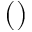Convert formula to latex. <formula><loc_0><loc_0><loc_500><loc_500>( )</formula> 